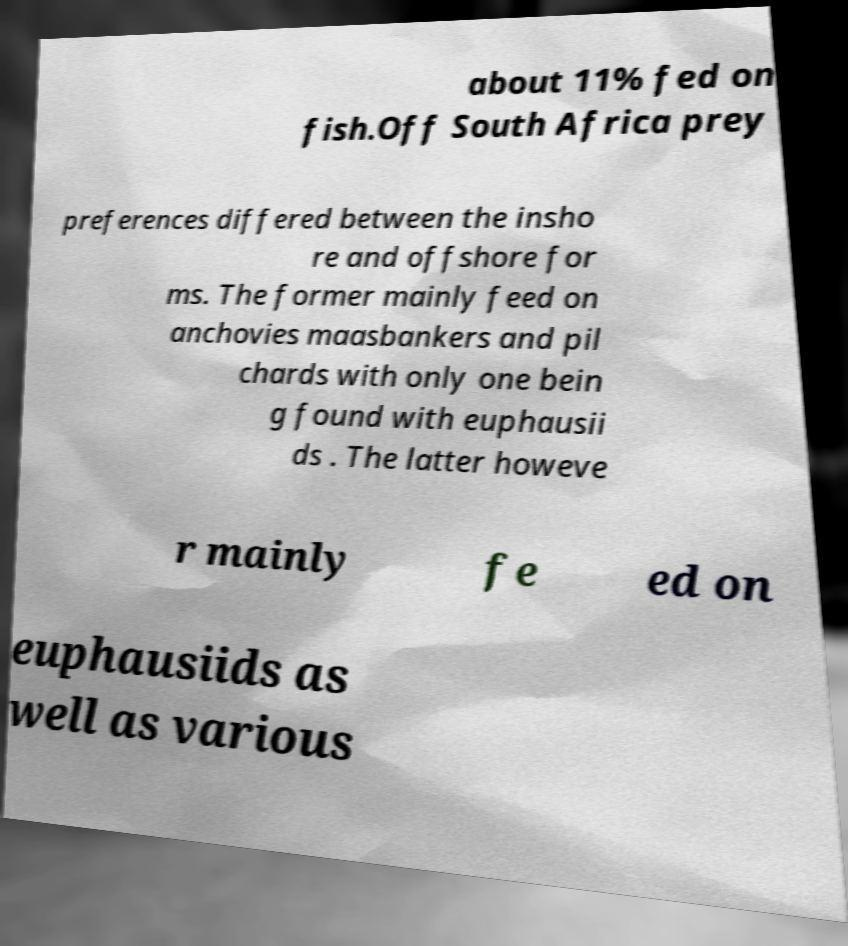What messages or text are displayed in this image? I need them in a readable, typed format. about 11% fed on fish.Off South Africa prey preferences differed between the insho re and offshore for ms. The former mainly feed on anchovies maasbankers and pil chards with only one bein g found with euphausii ds . The latter howeve r mainly fe ed on euphausiids as well as various 